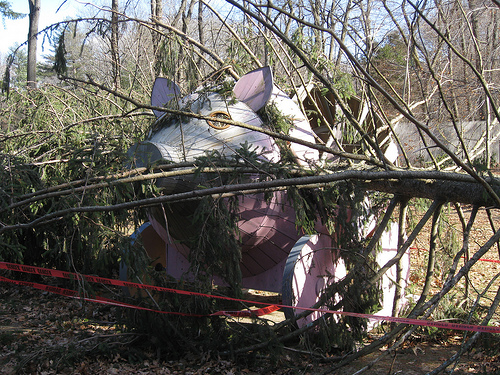<image>
Is the tree behind the tape? Yes. From this viewpoint, the tree is positioned behind the tape, with the tape partially or fully occluding the tree. Is the pig in the tree? Yes. The pig is contained within or inside the tree, showing a containment relationship. 